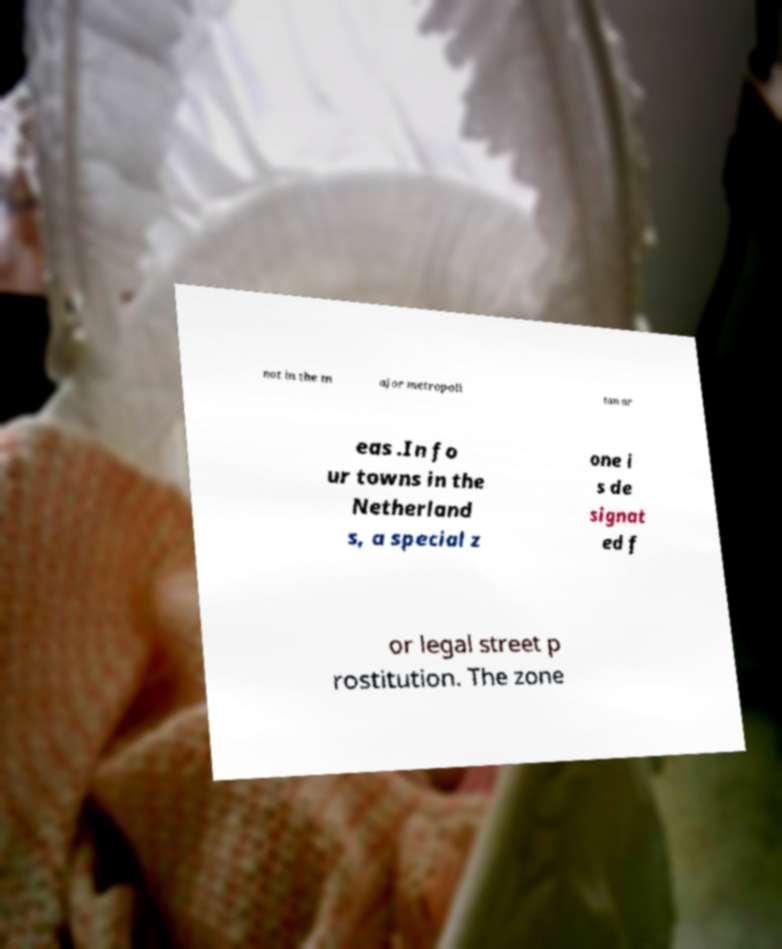For documentation purposes, I need the text within this image transcribed. Could you provide that? not in the m ajor metropoli tan ar eas .In fo ur towns in the Netherland s, a special z one i s de signat ed f or legal street p rostitution. The zone 